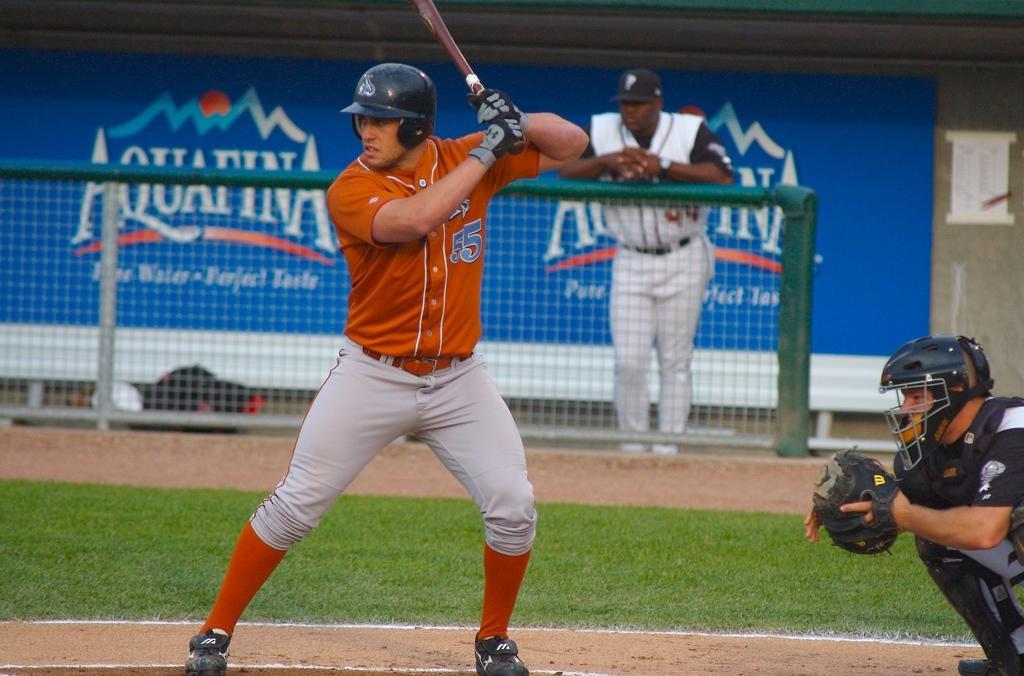How would you summarize this image in a sentence or two? In the center of the image we can see a man standing and holding a bat. On the right there is a wicket keeper. In the background there is a mesh and we can see a man standing. At the bottom there is ground and we can see a board. 